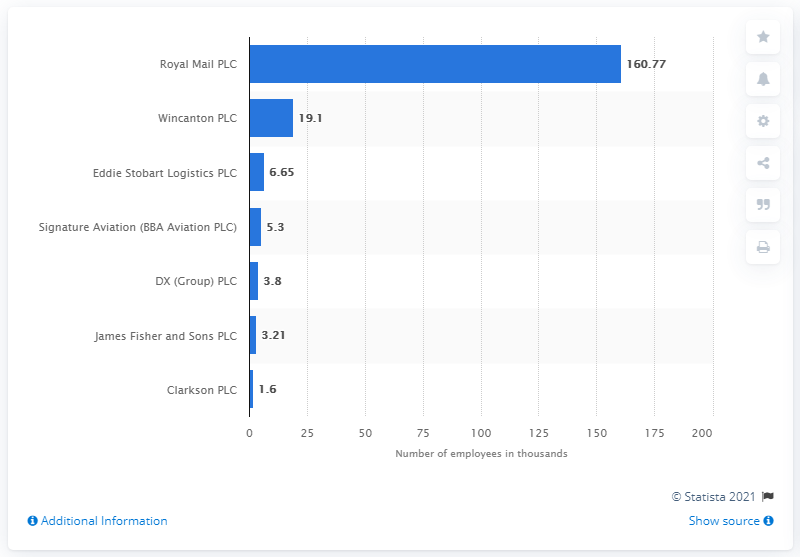Outline some significant characteristics in this image. Wincanton PLC is the largest employer in the industrial transportation industry in the United Kingdom. The largest employer in the industrial transportation industry in the UK is Royal Mail PLC. 